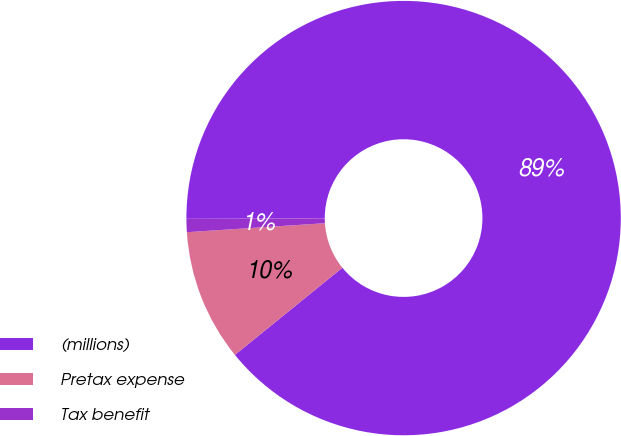<chart> <loc_0><loc_0><loc_500><loc_500><pie_chart><fcel>(millions)<fcel>Pretax expense<fcel>Tax benefit<nl><fcel>89.21%<fcel>9.81%<fcel>0.98%<nl></chart> 